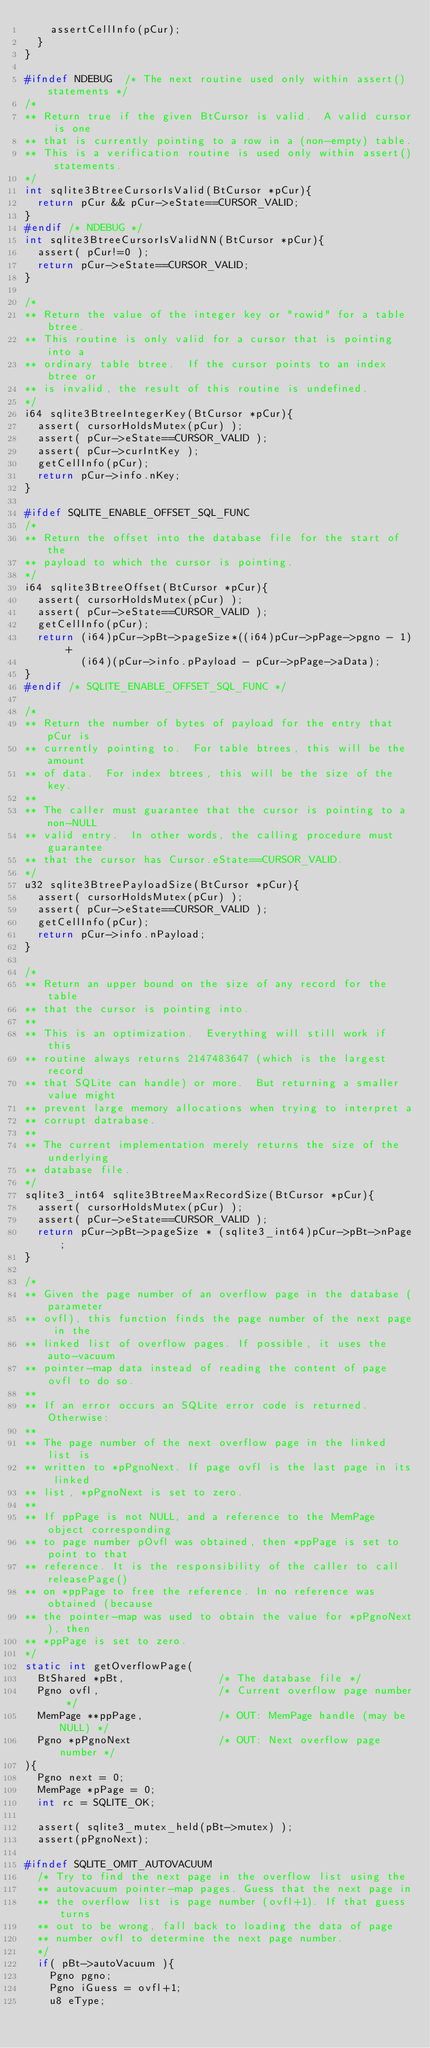<code> <loc_0><loc_0><loc_500><loc_500><_C_>    assertCellInfo(pCur);
  }
}

#ifndef NDEBUG  /* The next routine used only within assert() statements */
/*
** Return true if the given BtCursor is valid.  A valid cursor is one
** that is currently pointing to a row in a (non-empty) table.
** This is a verification routine is used only within assert() statements.
*/
int sqlite3BtreeCursorIsValid(BtCursor *pCur){
  return pCur && pCur->eState==CURSOR_VALID;
}
#endif /* NDEBUG */
int sqlite3BtreeCursorIsValidNN(BtCursor *pCur){
  assert( pCur!=0 );
  return pCur->eState==CURSOR_VALID;
}

/*
** Return the value of the integer key or "rowid" for a table btree.
** This routine is only valid for a cursor that is pointing into a
** ordinary table btree.  If the cursor points to an index btree or
** is invalid, the result of this routine is undefined.
*/
i64 sqlite3BtreeIntegerKey(BtCursor *pCur){
  assert( cursorHoldsMutex(pCur) );
  assert( pCur->eState==CURSOR_VALID );
  assert( pCur->curIntKey );
  getCellInfo(pCur);
  return pCur->info.nKey;
}

#ifdef SQLITE_ENABLE_OFFSET_SQL_FUNC
/*
** Return the offset into the database file for the start of the
** payload to which the cursor is pointing.
*/
i64 sqlite3BtreeOffset(BtCursor *pCur){
  assert( cursorHoldsMutex(pCur) );
  assert( pCur->eState==CURSOR_VALID );
  getCellInfo(pCur);
  return (i64)pCur->pBt->pageSize*((i64)pCur->pPage->pgno - 1) +
         (i64)(pCur->info.pPayload - pCur->pPage->aData);
}
#endif /* SQLITE_ENABLE_OFFSET_SQL_FUNC */

/*
** Return the number of bytes of payload for the entry that pCur is
** currently pointing to.  For table btrees, this will be the amount
** of data.  For index btrees, this will be the size of the key.
**
** The caller must guarantee that the cursor is pointing to a non-NULL
** valid entry.  In other words, the calling procedure must guarantee
** that the cursor has Cursor.eState==CURSOR_VALID.
*/
u32 sqlite3BtreePayloadSize(BtCursor *pCur){
  assert( cursorHoldsMutex(pCur) );
  assert( pCur->eState==CURSOR_VALID );
  getCellInfo(pCur);
  return pCur->info.nPayload;
}

/*
** Return an upper bound on the size of any record for the table
** that the cursor is pointing into.
**
** This is an optimization.  Everything will still work if this
** routine always returns 2147483647 (which is the largest record
** that SQLite can handle) or more.  But returning a smaller value might
** prevent large memory allocations when trying to interpret a
** corrupt datrabase.
**
** The current implementation merely returns the size of the underlying
** database file.
*/
sqlite3_int64 sqlite3BtreeMaxRecordSize(BtCursor *pCur){
  assert( cursorHoldsMutex(pCur) );
  assert( pCur->eState==CURSOR_VALID );
  return pCur->pBt->pageSize * (sqlite3_int64)pCur->pBt->nPage;
}

/*
** Given the page number of an overflow page in the database (parameter
** ovfl), this function finds the page number of the next page in the 
** linked list of overflow pages. If possible, it uses the auto-vacuum
** pointer-map data instead of reading the content of page ovfl to do so. 
**
** If an error occurs an SQLite error code is returned. Otherwise:
**
** The page number of the next overflow page in the linked list is 
** written to *pPgnoNext. If page ovfl is the last page in its linked 
** list, *pPgnoNext is set to zero. 
**
** If ppPage is not NULL, and a reference to the MemPage object corresponding
** to page number pOvfl was obtained, then *ppPage is set to point to that
** reference. It is the responsibility of the caller to call releasePage()
** on *ppPage to free the reference. In no reference was obtained (because
** the pointer-map was used to obtain the value for *pPgnoNext), then
** *ppPage is set to zero.
*/
static int getOverflowPage(
  BtShared *pBt,               /* The database file */
  Pgno ovfl,                   /* Current overflow page number */
  MemPage **ppPage,            /* OUT: MemPage handle (may be NULL) */
  Pgno *pPgnoNext              /* OUT: Next overflow page number */
){
  Pgno next = 0;
  MemPage *pPage = 0;
  int rc = SQLITE_OK;

  assert( sqlite3_mutex_held(pBt->mutex) );
  assert(pPgnoNext);

#ifndef SQLITE_OMIT_AUTOVACUUM
  /* Try to find the next page in the overflow list using the
  ** autovacuum pointer-map pages. Guess that the next page in 
  ** the overflow list is page number (ovfl+1). If that guess turns 
  ** out to be wrong, fall back to loading the data of page 
  ** number ovfl to determine the next page number.
  */
  if( pBt->autoVacuum ){
    Pgno pgno;
    Pgno iGuess = ovfl+1;
    u8 eType;
</code> 